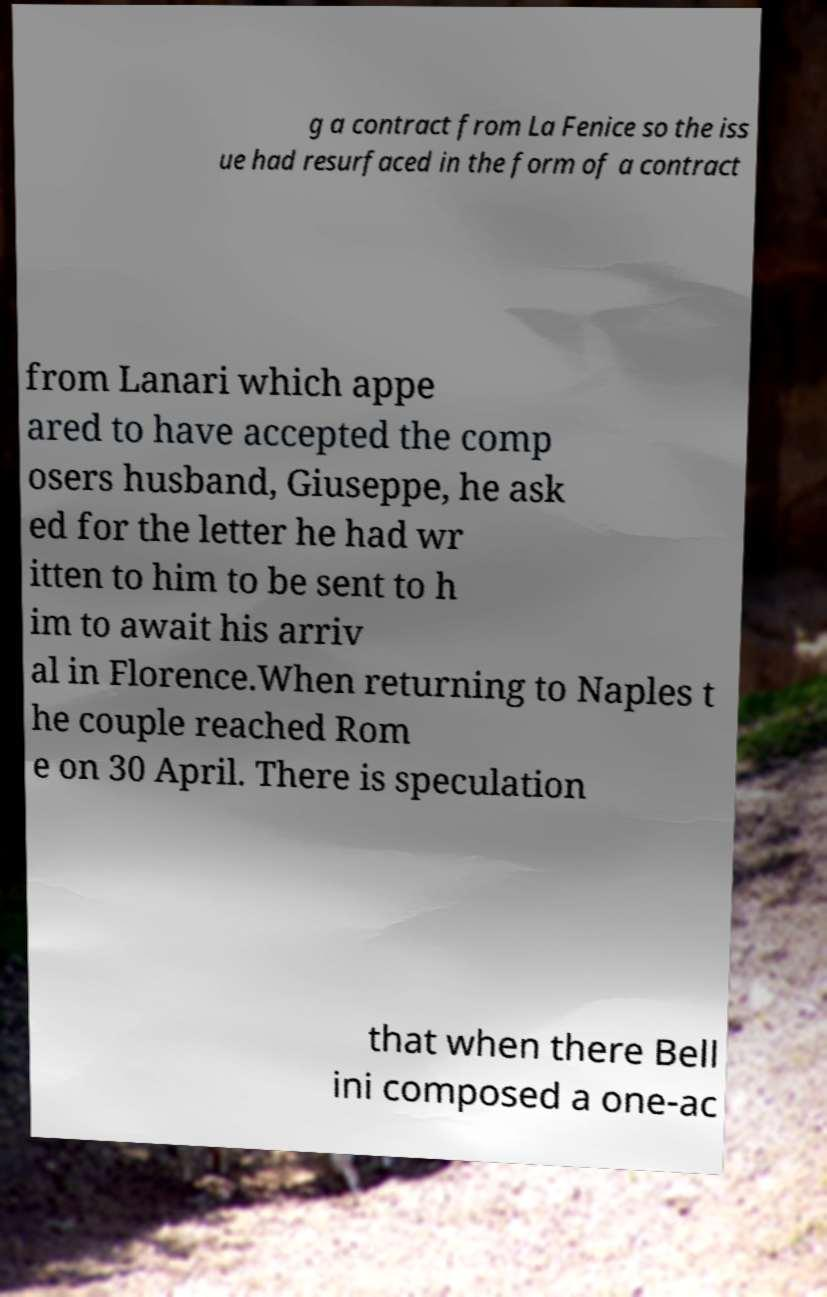Can you read and provide the text displayed in the image?This photo seems to have some interesting text. Can you extract and type it out for me? g a contract from La Fenice so the iss ue had resurfaced in the form of a contract from Lanari which appe ared to have accepted the comp osers husband, Giuseppe, he ask ed for the letter he had wr itten to him to be sent to h im to await his arriv al in Florence.When returning to Naples t he couple reached Rom e on 30 April. There is speculation that when there Bell ini composed a one-ac 